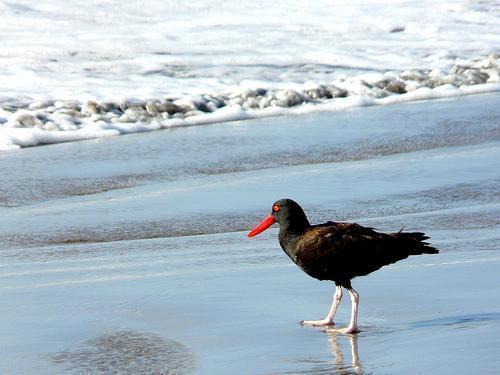How many animals are in the picture?
Give a very brief answer. 1. 